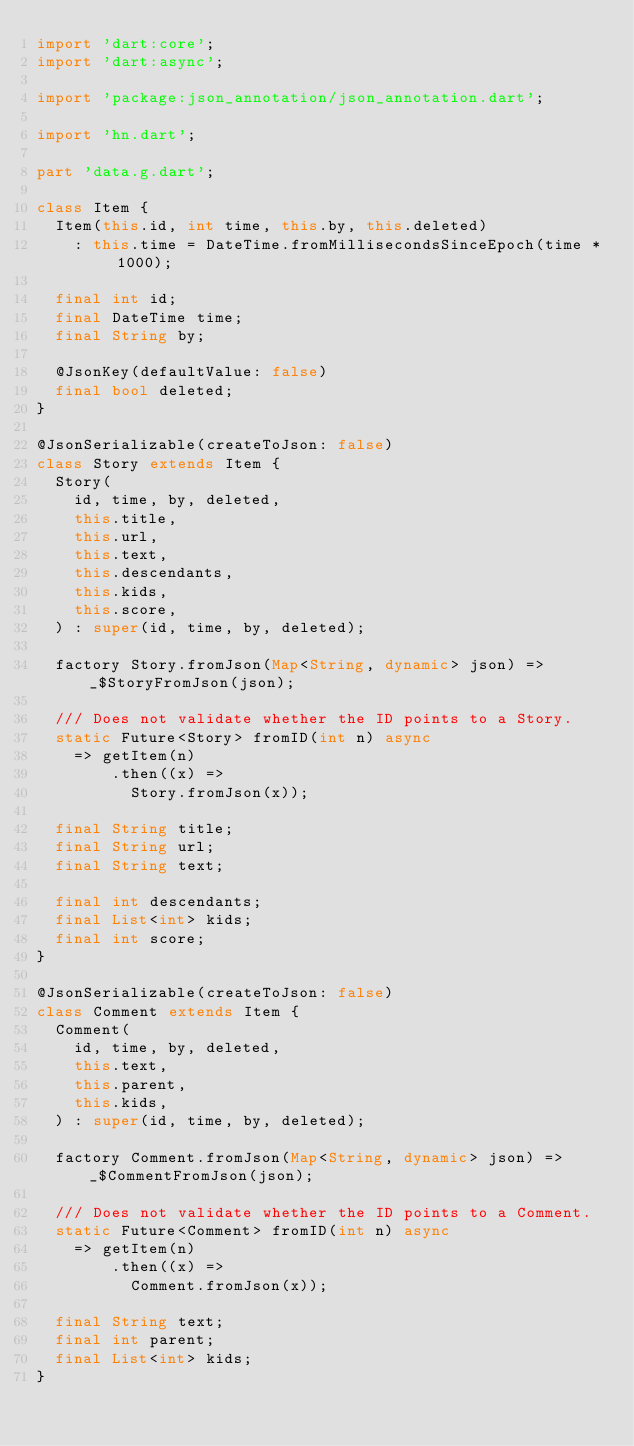Convert code to text. <code><loc_0><loc_0><loc_500><loc_500><_Dart_>import 'dart:core';
import 'dart:async';

import 'package:json_annotation/json_annotation.dart';

import 'hn.dart';

part 'data.g.dart';

class Item {
  Item(this.id, int time, this.by, this.deleted)
    : this.time = DateTime.fromMillisecondsSinceEpoch(time * 1000);

  final int id;
  final DateTime time;
  final String by;

  @JsonKey(defaultValue: false)
  final bool deleted;
}

@JsonSerializable(createToJson: false)
class Story extends Item {
  Story(
    id, time, by, deleted,
    this.title,
    this.url,
    this.text,
    this.descendants,
    this.kids,
    this.score,
  ) : super(id, time, by, deleted);

  factory Story.fromJson(Map<String, dynamic> json) => _$StoryFromJson(json);

  /// Does not validate whether the ID points to a Story.
  static Future<Story> fromID(int n) async
    => getItem(n)
        .then((x) =>
          Story.fromJson(x));

  final String title;
  final String url;
  final String text;

  final int descendants;
  final List<int> kids;
  final int score;
}

@JsonSerializable(createToJson: false)
class Comment extends Item {
  Comment(
    id, time, by, deleted,
    this.text,
    this.parent,
    this.kids,
  ) : super(id, time, by, deleted);

  factory Comment.fromJson(Map<String, dynamic> json) => _$CommentFromJson(json);

  /// Does not validate whether the ID points to a Comment.
  static Future<Comment> fromID(int n) async
    => getItem(n)
        .then((x) =>
          Comment.fromJson(x));

  final String text;
  final int parent;
  final List<int> kids;
}
</code> 